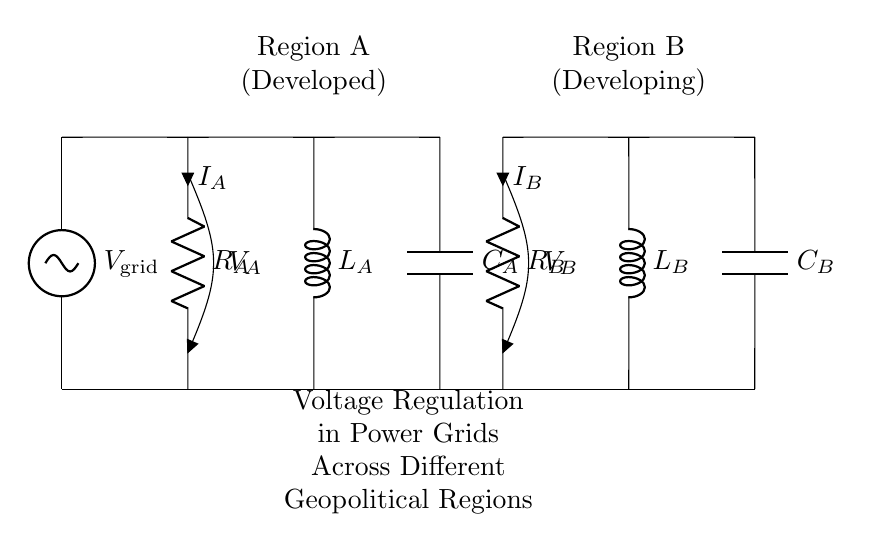What is the voltage at the measurement point in Region A? The measurement point in Region A is connected directly to the voltage source, so its voltage is equal to the supply voltage of the grid. The exact value is not specified in the circuit diagram, but it is labeled as the voltage of the grid.
Answer: V grid What type of component is used for voltage regulation in Region A? The component that primarily regulates voltage levels in Region A is the resistor, denoted by R_A. Resistors limit current flow and can help manage voltage drops across the circuit.
Answer: Resistor What is the function of the inductor in Region B? The inductor, labeled L_B, primarily stores energy in a magnetic field when electrical current passes through it. It can influence voltage stability by opposing changes in current flow, which can be essential in maintaining voltage regulation under varying loads.
Answer: Store energy How do the resistors in both regions compare? The resistors R_A and R_B serve similar roles in their respective regions, but their specific values are not stated in the diagram. A comparison would require knowing their resistive values as they impact current flow and voltage drops, reflecting the differences in infrastructure between a developed and a developing region.
Answer: Comparison requires values What components are present in Region B? In Region B, the components are a resistor (R_B), an inductor (L_B), and a capacitor (C_B). Each component has a specific role in voltage regulation and energy management, contributing to the overall stability of power distribution in that region.
Answer: Resistor, inductor, capacitor How does the capacitor contribute to voltage regulation? The capacitor, like C_A and C_B, helps smooth out voltage fluctuations in the circuit. It can store and release energy as needed, thus playing a key role in stabilizing voltage during load changes and improving the overall efficiency of power delivery.
Answer: Smooth voltage fluctuations 